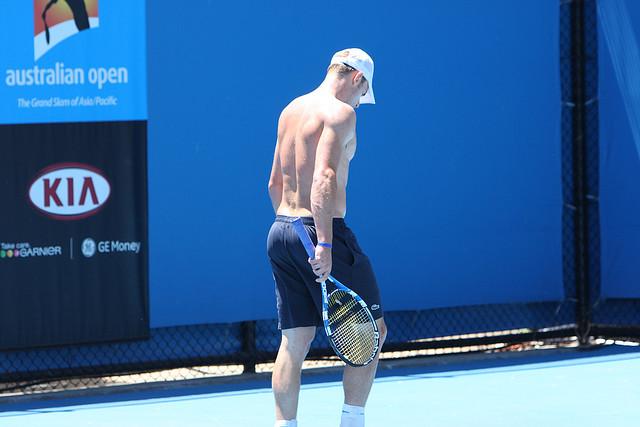In what country is this event?
Concise answer only. Australia. What car manufacturer sponsors this tournament?
Short answer required. Kia. What color is the bracelet?
Give a very brief answer. Blue. 